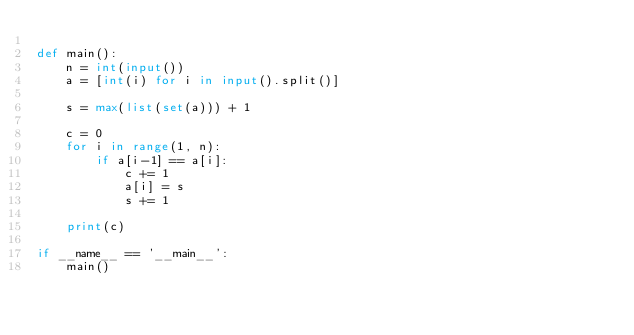<code> <loc_0><loc_0><loc_500><loc_500><_Python_>
def main():
    n = int(input())
    a = [int(i) for i in input().split()]

    s = max(list(set(a))) + 1
    
    c = 0
    for i in range(1, n):
        if a[i-1] == a[i]:
            c += 1
            a[i] = s
            s += 1

    print(c)
            
if __name__ == '__main__':
    main()
</code> 